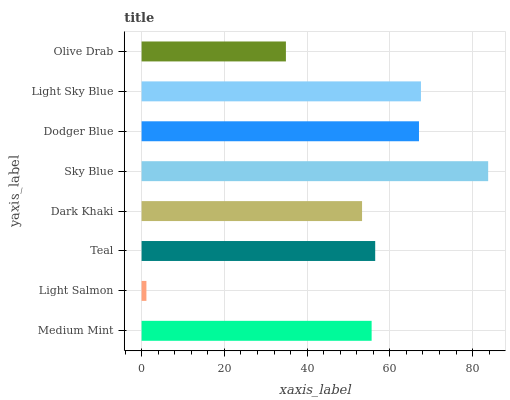Is Light Salmon the minimum?
Answer yes or no. Yes. Is Sky Blue the maximum?
Answer yes or no. Yes. Is Teal the minimum?
Answer yes or no. No. Is Teal the maximum?
Answer yes or no. No. Is Teal greater than Light Salmon?
Answer yes or no. Yes. Is Light Salmon less than Teal?
Answer yes or no. Yes. Is Light Salmon greater than Teal?
Answer yes or no. No. Is Teal less than Light Salmon?
Answer yes or no. No. Is Teal the high median?
Answer yes or no. Yes. Is Medium Mint the low median?
Answer yes or no. Yes. Is Light Salmon the high median?
Answer yes or no. No. Is Dodger Blue the low median?
Answer yes or no. No. 